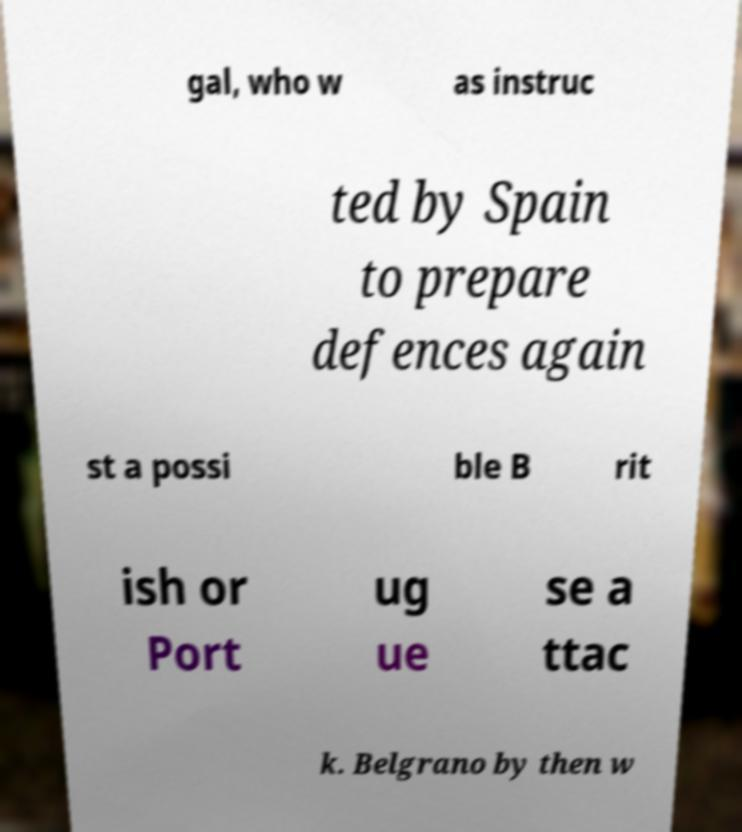Could you extract and type out the text from this image? gal, who w as instruc ted by Spain to prepare defences again st a possi ble B rit ish or Port ug ue se a ttac k. Belgrano by then w 